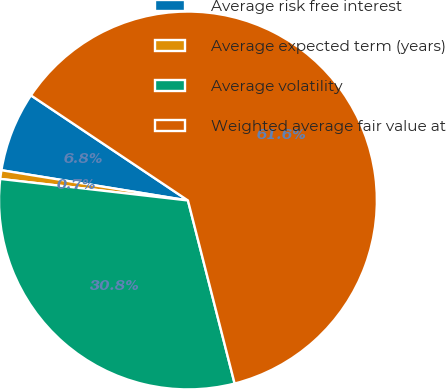Convert chart. <chart><loc_0><loc_0><loc_500><loc_500><pie_chart><fcel>Average risk free interest<fcel>Average expected term (years)<fcel>Average volatility<fcel>Weighted average fair value at<nl><fcel>6.83%<fcel>0.74%<fcel>30.79%<fcel>61.63%<nl></chart> 